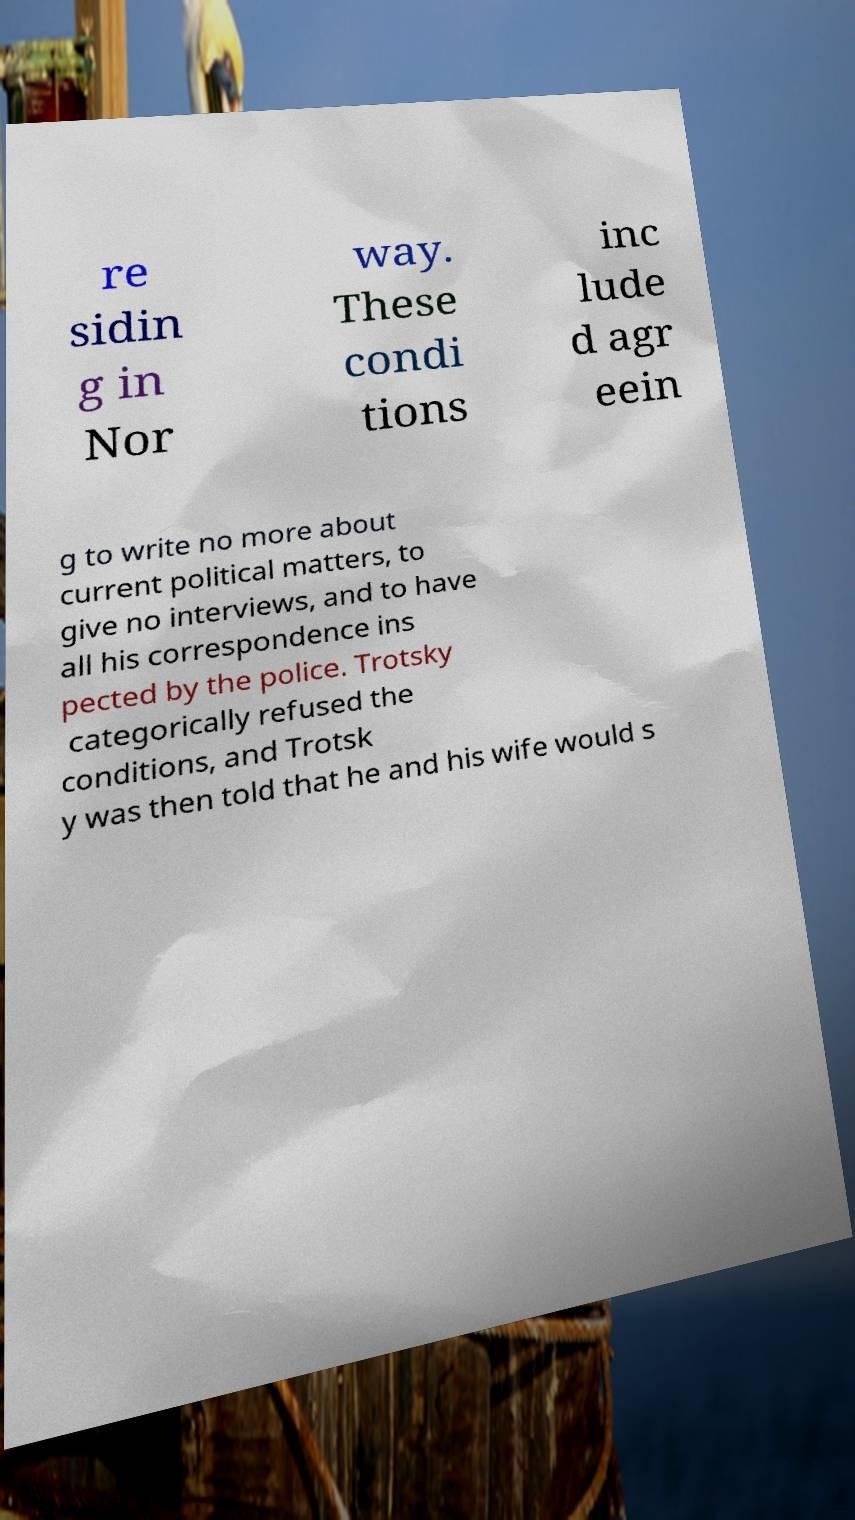Please read and relay the text visible in this image. What does it say? re sidin g in Nor way. These condi tions inc lude d agr eein g to write no more about current political matters, to give no interviews, and to have all his correspondence ins pected by the police. Trotsky categorically refused the conditions, and Trotsk y was then told that he and his wife would s 